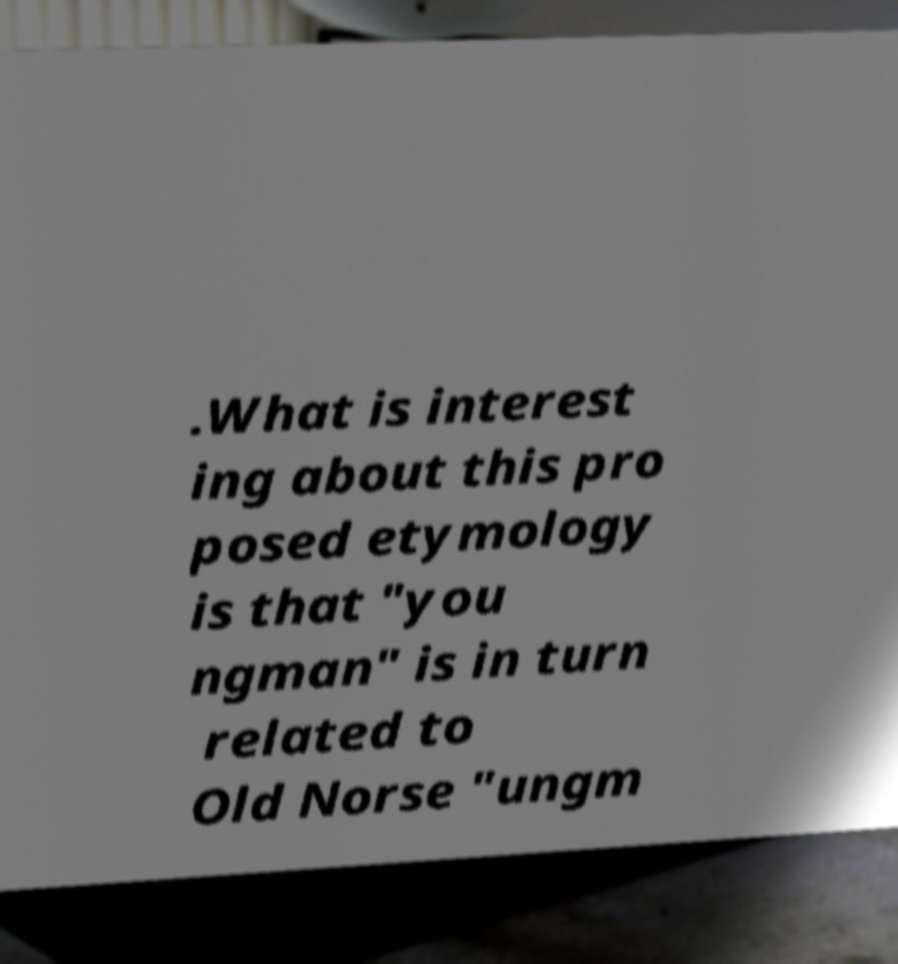Could you extract and type out the text from this image? .What is interest ing about this pro posed etymology is that "you ngman" is in turn related to Old Norse "ungm 